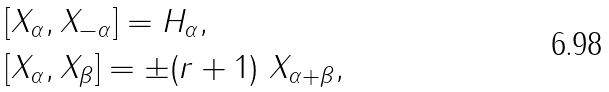<formula> <loc_0><loc_0><loc_500><loc_500>& [ X _ { \alpha } , X _ { - \alpha } ] = H _ { \alpha } , \\ & [ X _ { \alpha } , X _ { \beta } ] = \pm ( r + 1 ) \ X _ { \alpha + \beta } ,</formula> 